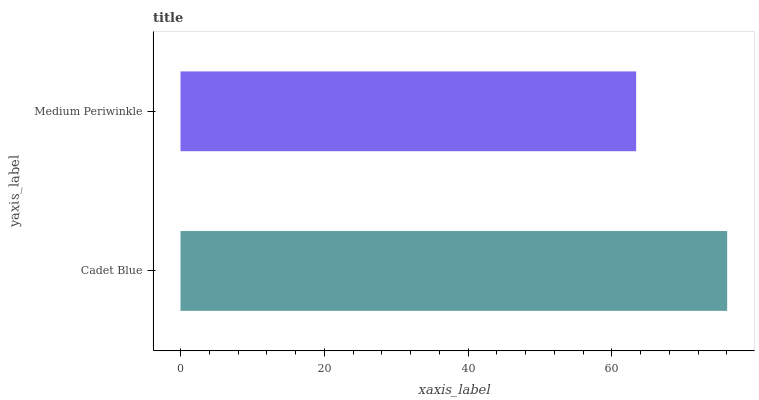Is Medium Periwinkle the minimum?
Answer yes or no. Yes. Is Cadet Blue the maximum?
Answer yes or no. Yes. Is Medium Periwinkle the maximum?
Answer yes or no. No. Is Cadet Blue greater than Medium Periwinkle?
Answer yes or no. Yes. Is Medium Periwinkle less than Cadet Blue?
Answer yes or no. Yes. Is Medium Periwinkle greater than Cadet Blue?
Answer yes or no. No. Is Cadet Blue less than Medium Periwinkle?
Answer yes or no. No. Is Cadet Blue the high median?
Answer yes or no. Yes. Is Medium Periwinkle the low median?
Answer yes or no. Yes. Is Medium Periwinkle the high median?
Answer yes or no. No. Is Cadet Blue the low median?
Answer yes or no. No. 